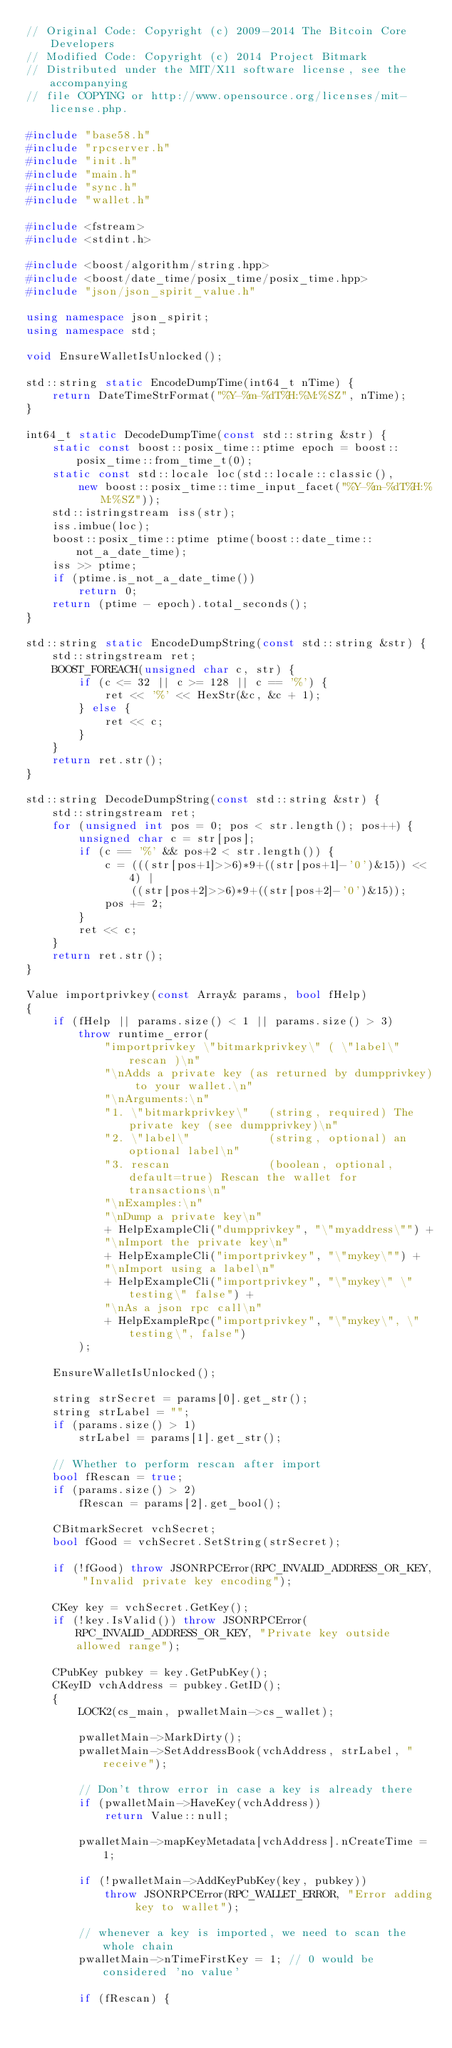Convert code to text. <code><loc_0><loc_0><loc_500><loc_500><_C++_>// Original Code: Copyright (c) 2009-2014 The Bitcoin Core Developers
// Modified Code: Copyright (c) 2014 Project Bitmark
// Distributed under the MIT/X11 software license, see the accompanying
// file COPYING or http://www.opensource.org/licenses/mit-license.php.

#include "base58.h"
#include "rpcserver.h"
#include "init.h"
#include "main.h"
#include "sync.h"
#include "wallet.h"

#include <fstream>
#include <stdint.h>

#include <boost/algorithm/string.hpp>
#include <boost/date_time/posix_time/posix_time.hpp>
#include "json/json_spirit_value.h"

using namespace json_spirit;
using namespace std;

void EnsureWalletIsUnlocked();

std::string static EncodeDumpTime(int64_t nTime) {
    return DateTimeStrFormat("%Y-%m-%dT%H:%M:%SZ", nTime);
}

int64_t static DecodeDumpTime(const std::string &str) {
    static const boost::posix_time::ptime epoch = boost::posix_time::from_time_t(0);
    static const std::locale loc(std::locale::classic(),
        new boost::posix_time::time_input_facet("%Y-%m-%dT%H:%M:%SZ"));
    std::istringstream iss(str);
    iss.imbue(loc);
    boost::posix_time::ptime ptime(boost::date_time::not_a_date_time);
    iss >> ptime;
    if (ptime.is_not_a_date_time())
        return 0;
    return (ptime - epoch).total_seconds();
}

std::string static EncodeDumpString(const std::string &str) {
    std::stringstream ret;
    BOOST_FOREACH(unsigned char c, str) {
        if (c <= 32 || c >= 128 || c == '%') {
            ret << '%' << HexStr(&c, &c + 1);
        } else {
            ret << c;
        }
    }
    return ret.str();
}

std::string DecodeDumpString(const std::string &str) {
    std::stringstream ret;
    for (unsigned int pos = 0; pos < str.length(); pos++) {
        unsigned char c = str[pos];
        if (c == '%' && pos+2 < str.length()) {
            c = (((str[pos+1]>>6)*9+((str[pos+1]-'0')&15)) << 4) | 
                ((str[pos+2]>>6)*9+((str[pos+2]-'0')&15));
            pos += 2;
        }
        ret << c;
    }
    return ret.str();
}

Value importprivkey(const Array& params, bool fHelp)
{
    if (fHelp || params.size() < 1 || params.size() > 3)
        throw runtime_error(
            "importprivkey \"bitmarkprivkey\" ( \"label\" rescan )\n"
            "\nAdds a private key (as returned by dumpprivkey) to your wallet.\n"
            "\nArguments:\n"
            "1. \"bitmarkprivkey\"   (string, required) The private key (see dumpprivkey)\n"
            "2. \"label\"            (string, optional) an optional label\n"
            "3. rescan               (boolean, optional, default=true) Rescan the wallet for transactions\n"
            "\nExamples:\n"
            "\nDump a private key\n"
            + HelpExampleCli("dumpprivkey", "\"myaddress\"") +
            "\nImport the private key\n"
            + HelpExampleCli("importprivkey", "\"mykey\"") +
            "\nImport using a label\n"
            + HelpExampleCli("importprivkey", "\"mykey\" \"testing\" false") +
            "\nAs a json rpc call\n"
            + HelpExampleRpc("importprivkey", "\"mykey\", \"testing\", false")
        );

    EnsureWalletIsUnlocked();

    string strSecret = params[0].get_str();
    string strLabel = "";
    if (params.size() > 1)
        strLabel = params[1].get_str();

    // Whether to perform rescan after import
    bool fRescan = true;
    if (params.size() > 2)
        fRescan = params[2].get_bool();

    CBitmarkSecret vchSecret;
    bool fGood = vchSecret.SetString(strSecret);

    if (!fGood) throw JSONRPCError(RPC_INVALID_ADDRESS_OR_KEY, "Invalid private key encoding");

    CKey key = vchSecret.GetKey();
    if (!key.IsValid()) throw JSONRPCError(RPC_INVALID_ADDRESS_OR_KEY, "Private key outside allowed range");

    CPubKey pubkey = key.GetPubKey();
    CKeyID vchAddress = pubkey.GetID();
    {
        LOCK2(cs_main, pwalletMain->cs_wallet);

        pwalletMain->MarkDirty();
        pwalletMain->SetAddressBook(vchAddress, strLabel, "receive");

        // Don't throw error in case a key is already there
        if (pwalletMain->HaveKey(vchAddress))
            return Value::null;

        pwalletMain->mapKeyMetadata[vchAddress].nCreateTime = 1;

        if (!pwalletMain->AddKeyPubKey(key, pubkey))
            throw JSONRPCError(RPC_WALLET_ERROR, "Error adding key to wallet");

        // whenever a key is imported, we need to scan the whole chain
        pwalletMain->nTimeFirstKey = 1; // 0 would be considered 'no value'

        if (fRescan) {</code> 